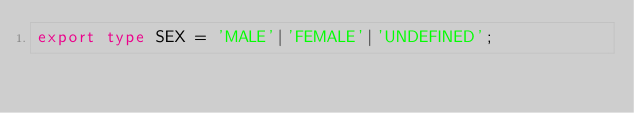Convert code to text. <code><loc_0><loc_0><loc_500><loc_500><_TypeScript_>export type SEX = 'MALE'|'FEMALE'|'UNDEFINED';
</code> 